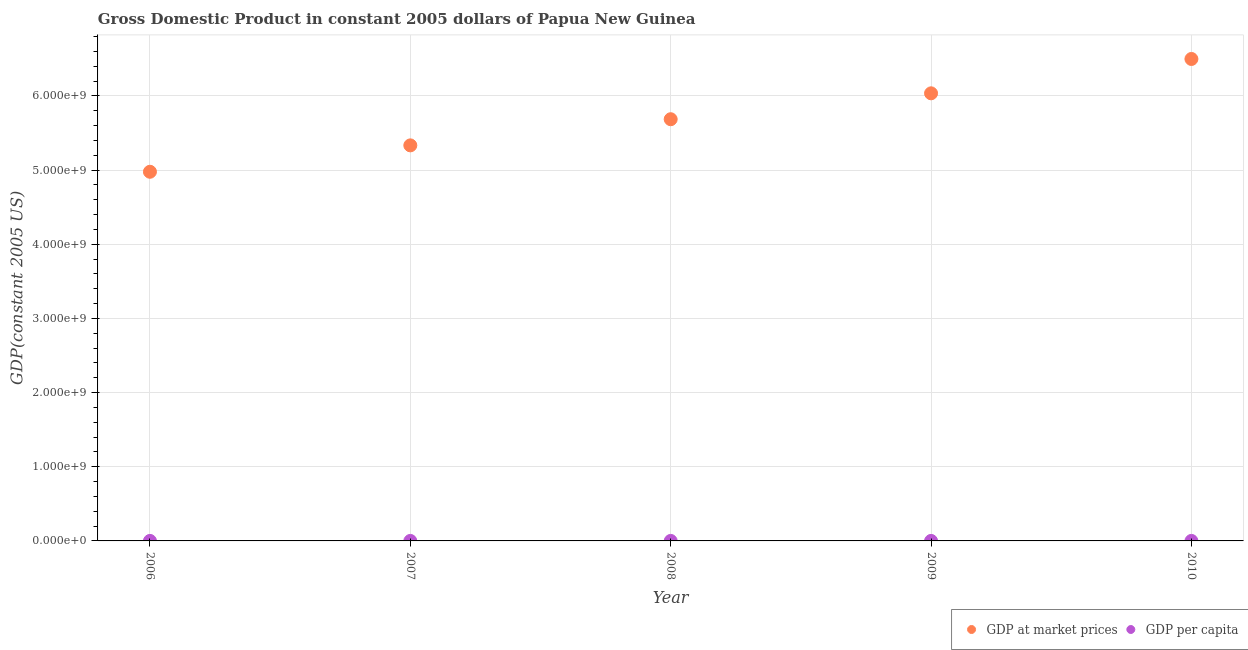Is the number of dotlines equal to the number of legend labels?
Keep it short and to the point. Yes. What is the gdp per capita in 2006?
Provide a short and direct response. 798.19. Across all years, what is the maximum gdp at market prices?
Your answer should be very brief. 6.50e+09. Across all years, what is the minimum gdp at market prices?
Offer a very short reply. 4.98e+09. In which year was the gdp at market prices maximum?
Ensure brevity in your answer.  2010. In which year was the gdp per capita minimum?
Offer a very short reply. 2006. What is the total gdp at market prices in the graph?
Give a very brief answer. 2.85e+1. What is the difference between the gdp per capita in 2009 and that in 2010?
Your response must be concise. -47.4. What is the difference between the gdp at market prices in 2007 and the gdp per capita in 2009?
Make the answer very short. 5.33e+09. What is the average gdp per capita per year?
Your answer should be compact. 870.66. In the year 2009, what is the difference between the gdp at market prices and gdp per capita?
Provide a short and direct response. 6.04e+09. In how many years, is the gdp at market prices greater than 5800000000 US$?
Keep it short and to the point. 2. What is the ratio of the gdp per capita in 2008 to that in 2009?
Give a very brief answer. 0.96. Is the gdp per capita in 2007 less than that in 2008?
Give a very brief answer. Yes. Is the difference between the gdp at market prices in 2006 and 2010 greater than the difference between the gdp per capita in 2006 and 2010?
Provide a short and direct response. No. What is the difference between the highest and the second highest gdp at market prices?
Your answer should be compact. 4.63e+08. What is the difference between the highest and the lowest gdp at market prices?
Your response must be concise. 1.52e+09. In how many years, is the gdp at market prices greater than the average gdp at market prices taken over all years?
Your response must be concise. 2. Is the sum of the gdp per capita in 2006 and 2008 greater than the maximum gdp at market prices across all years?
Make the answer very short. No. Is the gdp at market prices strictly greater than the gdp per capita over the years?
Ensure brevity in your answer.  Yes. Is the gdp at market prices strictly less than the gdp per capita over the years?
Offer a terse response. No. How many years are there in the graph?
Give a very brief answer. 5. What is the difference between two consecutive major ticks on the Y-axis?
Your answer should be very brief. 1.00e+09. Are the values on the major ticks of Y-axis written in scientific E-notation?
Ensure brevity in your answer.  Yes. Does the graph contain any zero values?
Your response must be concise. No. Does the graph contain grids?
Give a very brief answer. Yes. How many legend labels are there?
Offer a very short reply. 2. How are the legend labels stacked?
Offer a terse response. Horizontal. What is the title of the graph?
Your answer should be very brief. Gross Domestic Product in constant 2005 dollars of Papua New Guinea. What is the label or title of the X-axis?
Offer a very short reply. Year. What is the label or title of the Y-axis?
Provide a succinct answer. GDP(constant 2005 US). What is the GDP(constant 2005 US) of GDP at market prices in 2006?
Your response must be concise. 4.98e+09. What is the GDP(constant 2005 US) in GDP per capita in 2006?
Provide a succinct answer. 798.19. What is the GDP(constant 2005 US) of GDP at market prices in 2007?
Your answer should be very brief. 5.33e+09. What is the GDP(constant 2005 US) of GDP per capita in 2007?
Ensure brevity in your answer.  835.01. What is the GDP(constant 2005 US) in GDP at market prices in 2008?
Your answer should be compact. 5.69e+09. What is the GDP(constant 2005 US) of GDP per capita in 2008?
Make the answer very short. 869.42. What is the GDP(constant 2005 US) of GDP at market prices in 2009?
Keep it short and to the point. 6.04e+09. What is the GDP(constant 2005 US) of GDP per capita in 2009?
Keep it short and to the point. 901.64. What is the GDP(constant 2005 US) in GDP at market prices in 2010?
Your answer should be very brief. 6.50e+09. What is the GDP(constant 2005 US) in GDP per capita in 2010?
Your response must be concise. 949.05. Across all years, what is the maximum GDP(constant 2005 US) in GDP at market prices?
Your answer should be very brief. 6.50e+09. Across all years, what is the maximum GDP(constant 2005 US) of GDP per capita?
Ensure brevity in your answer.  949.05. Across all years, what is the minimum GDP(constant 2005 US) of GDP at market prices?
Your answer should be very brief. 4.98e+09. Across all years, what is the minimum GDP(constant 2005 US) in GDP per capita?
Your response must be concise. 798.19. What is the total GDP(constant 2005 US) of GDP at market prices in the graph?
Your answer should be very brief. 2.85e+1. What is the total GDP(constant 2005 US) of GDP per capita in the graph?
Provide a succinct answer. 4353.3. What is the difference between the GDP(constant 2005 US) in GDP at market prices in 2006 and that in 2007?
Offer a very short reply. -3.56e+08. What is the difference between the GDP(constant 2005 US) of GDP per capita in 2006 and that in 2007?
Your answer should be very brief. -36.82. What is the difference between the GDP(constant 2005 US) in GDP at market prices in 2006 and that in 2008?
Your response must be concise. -7.09e+08. What is the difference between the GDP(constant 2005 US) of GDP per capita in 2006 and that in 2008?
Your answer should be compact. -71.23. What is the difference between the GDP(constant 2005 US) of GDP at market prices in 2006 and that in 2009?
Your answer should be compact. -1.06e+09. What is the difference between the GDP(constant 2005 US) of GDP per capita in 2006 and that in 2009?
Offer a terse response. -103.46. What is the difference between the GDP(constant 2005 US) in GDP at market prices in 2006 and that in 2010?
Keep it short and to the point. -1.52e+09. What is the difference between the GDP(constant 2005 US) of GDP per capita in 2006 and that in 2010?
Offer a terse response. -150.86. What is the difference between the GDP(constant 2005 US) of GDP at market prices in 2007 and that in 2008?
Keep it short and to the point. -3.53e+08. What is the difference between the GDP(constant 2005 US) in GDP per capita in 2007 and that in 2008?
Give a very brief answer. -34.4. What is the difference between the GDP(constant 2005 US) of GDP at market prices in 2007 and that in 2009?
Make the answer very short. -7.02e+08. What is the difference between the GDP(constant 2005 US) of GDP per capita in 2007 and that in 2009?
Give a very brief answer. -66.63. What is the difference between the GDP(constant 2005 US) of GDP at market prices in 2007 and that in 2010?
Provide a succinct answer. -1.16e+09. What is the difference between the GDP(constant 2005 US) of GDP per capita in 2007 and that in 2010?
Provide a short and direct response. -114.03. What is the difference between the GDP(constant 2005 US) of GDP at market prices in 2008 and that in 2009?
Give a very brief answer. -3.49e+08. What is the difference between the GDP(constant 2005 US) in GDP per capita in 2008 and that in 2009?
Offer a very short reply. -32.23. What is the difference between the GDP(constant 2005 US) of GDP at market prices in 2008 and that in 2010?
Provide a succinct answer. -8.12e+08. What is the difference between the GDP(constant 2005 US) of GDP per capita in 2008 and that in 2010?
Keep it short and to the point. -79.63. What is the difference between the GDP(constant 2005 US) of GDP at market prices in 2009 and that in 2010?
Offer a terse response. -4.63e+08. What is the difference between the GDP(constant 2005 US) in GDP per capita in 2009 and that in 2010?
Your response must be concise. -47.4. What is the difference between the GDP(constant 2005 US) in GDP at market prices in 2006 and the GDP(constant 2005 US) in GDP per capita in 2007?
Your response must be concise. 4.98e+09. What is the difference between the GDP(constant 2005 US) in GDP at market prices in 2006 and the GDP(constant 2005 US) in GDP per capita in 2008?
Make the answer very short. 4.98e+09. What is the difference between the GDP(constant 2005 US) of GDP at market prices in 2006 and the GDP(constant 2005 US) of GDP per capita in 2009?
Make the answer very short. 4.98e+09. What is the difference between the GDP(constant 2005 US) in GDP at market prices in 2006 and the GDP(constant 2005 US) in GDP per capita in 2010?
Your answer should be compact. 4.98e+09. What is the difference between the GDP(constant 2005 US) in GDP at market prices in 2007 and the GDP(constant 2005 US) in GDP per capita in 2008?
Keep it short and to the point. 5.33e+09. What is the difference between the GDP(constant 2005 US) in GDP at market prices in 2007 and the GDP(constant 2005 US) in GDP per capita in 2009?
Your answer should be very brief. 5.33e+09. What is the difference between the GDP(constant 2005 US) in GDP at market prices in 2007 and the GDP(constant 2005 US) in GDP per capita in 2010?
Provide a succinct answer. 5.33e+09. What is the difference between the GDP(constant 2005 US) of GDP at market prices in 2008 and the GDP(constant 2005 US) of GDP per capita in 2009?
Your response must be concise. 5.69e+09. What is the difference between the GDP(constant 2005 US) in GDP at market prices in 2008 and the GDP(constant 2005 US) in GDP per capita in 2010?
Provide a succinct answer. 5.69e+09. What is the difference between the GDP(constant 2005 US) in GDP at market prices in 2009 and the GDP(constant 2005 US) in GDP per capita in 2010?
Provide a succinct answer. 6.04e+09. What is the average GDP(constant 2005 US) in GDP at market prices per year?
Your response must be concise. 5.71e+09. What is the average GDP(constant 2005 US) in GDP per capita per year?
Provide a succinct answer. 870.66. In the year 2006, what is the difference between the GDP(constant 2005 US) of GDP at market prices and GDP(constant 2005 US) of GDP per capita?
Make the answer very short. 4.98e+09. In the year 2007, what is the difference between the GDP(constant 2005 US) of GDP at market prices and GDP(constant 2005 US) of GDP per capita?
Your answer should be compact. 5.33e+09. In the year 2008, what is the difference between the GDP(constant 2005 US) in GDP at market prices and GDP(constant 2005 US) in GDP per capita?
Offer a terse response. 5.69e+09. In the year 2009, what is the difference between the GDP(constant 2005 US) in GDP at market prices and GDP(constant 2005 US) in GDP per capita?
Your answer should be compact. 6.04e+09. In the year 2010, what is the difference between the GDP(constant 2005 US) of GDP at market prices and GDP(constant 2005 US) of GDP per capita?
Keep it short and to the point. 6.50e+09. What is the ratio of the GDP(constant 2005 US) of GDP per capita in 2006 to that in 2007?
Make the answer very short. 0.96. What is the ratio of the GDP(constant 2005 US) in GDP at market prices in 2006 to that in 2008?
Offer a terse response. 0.88. What is the ratio of the GDP(constant 2005 US) of GDP per capita in 2006 to that in 2008?
Ensure brevity in your answer.  0.92. What is the ratio of the GDP(constant 2005 US) of GDP at market prices in 2006 to that in 2009?
Your answer should be very brief. 0.82. What is the ratio of the GDP(constant 2005 US) in GDP per capita in 2006 to that in 2009?
Give a very brief answer. 0.89. What is the ratio of the GDP(constant 2005 US) in GDP at market prices in 2006 to that in 2010?
Keep it short and to the point. 0.77. What is the ratio of the GDP(constant 2005 US) in GDP per capita in 2006 to that in 2010?
Provide a short and direct response. 0.84. What is the ratio of the GDP(constant 2005 US) of GDP at market prices in 2007 to that in 2008?
Offer a terse response. 0.94. What is the ratio of the GDP(constant 2005 US) of GDP per capita in 2007 to that in 2008?
Ensure brevity in your answer.  0.96. What is the ratio of the GDP(constant 2005 US) in GDP at market prices in 2007 to that in 2009?
Your answer should be compact. 0.88. What is the ratio of the GDP(constant 2005 US) of GDP per capita in 2007 to that in 2009?
Your answer should be very brief. 0.93. What is the ratio of the GDP(constant 2005 US) in GDP at market prices in 2007 to that in 2010?
Offer a terse response. 0.82. What is the ratio of the GDP(constant 2005 US) of GDP per capita in 2007 to that in 2010?
Keep it short and to the point. 0.88. What is the ratio of the GDP(constant 2005 US) of GDP at market prices in 2008 to that in 2009?
Your answer should be very brief. 0.94. What is the ratio of the GDP(constant 2005 US) in GDP per capita in 2008 to that in 2009?
Give a very brief answer. 0.96. What is the ratio of the GDP(constant 2005 US) of GDP per capita in 2008 to that in 2010?
Make the answer very short. 0.92. What is the ratio of the GDP(constant 2005 US) in GDP at market prices in 2009 to that in 2010?
Keep it short and to the point. 0.93. What is the ratio of the GDP(constant 2005 US) of GDP per capita in 2009 to that in 2010?
Your response must be concise. 0.95. What is the difference between the highest and the second highest GDP(constant 2005 US) of GDP at market prices?
Provide a short and direct response. 4.63e+08. What is the difference between the highest and the second highest GDP(constant 2005 US) in GDP per capita?
Provide a short and direct response. 47.4. What is the difference between the highest and the lowest GDP(constant 2005 US) of GDP at market prices?
Make the answer very short. 1.52e+09. What is the difference between the highest and the lowest GDP(constant 2005 US) in GDP per capita?
Offer a terse response. 150.86. 